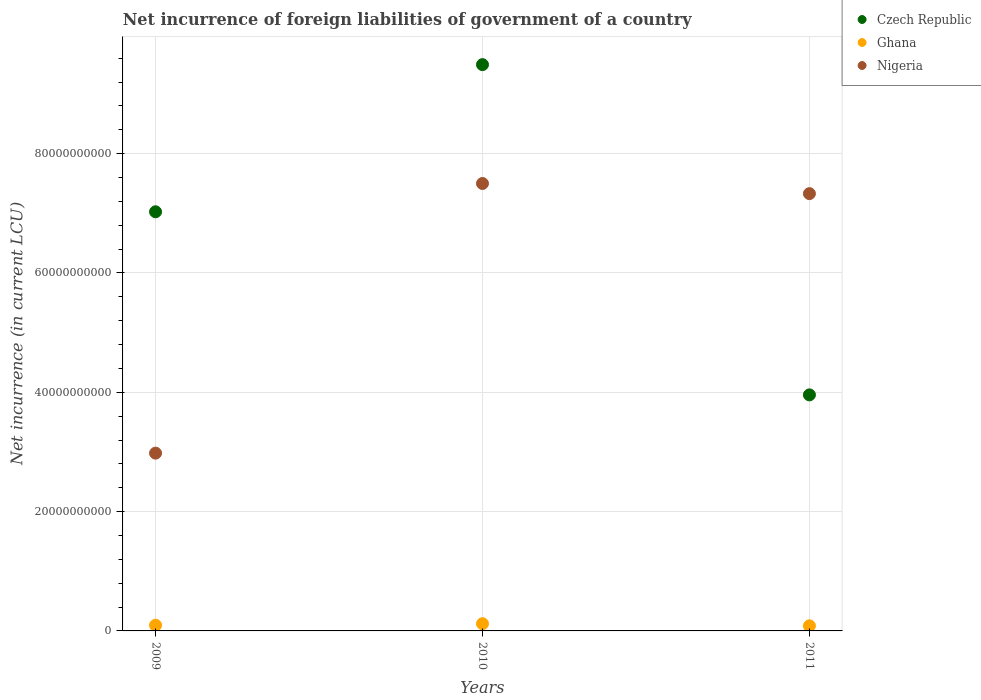How many different coloured dotlines are there?
Provide a short and direct response. 3. What is the net incurrence of foreign liabilities in Nigeria in 2010?
Give a very brief answer. 7.50e+1. Across all years, what is the maximum net incurrence of foreign liabilities in Ghana?
Provide a short and direct response. 1.21e+09. Across all years, what is the minimum net incurrence of foreign liabilities in Nigeria?
Keep it short and to the point. 2.98e+1. What is the total net incurrence of foreign liabilities in Ghana in the graph?
Make the answer very short. 3.02e+09. What is the difference between the net incurrence of foreign liabilities in Ghana in 2010 and that in 2011?
Make the answer very short. 3.53e+08. What is the difference between the net incurrence of foreign liabilities in Ghana in 2011 and the net incurrence of foreign liabilities in Nigeria in 2009?
Your answer should be compact. -2.89e+1. What is the average net incurrence of foreign liabilities in Nigeria per year?
Make the answer very short. 5.94e+1. In the year 2010, what is the difference between the net incurrence of foreign liabilities in Nigeria and net incurrence of foreign liabilities in Ghana?
Give a very brief answer. 7.38e+1. What is the ratio of the net incurrence of foreign liabilities in Nigeria in 2010 to that in 2011?
Give a very brief answer. 1.02. Is the net incurrence of foreign liabilities in Ghana in 2009 less than that in 2011?
Give a very brief answer. No. What is the difference between the highest and the second highest net incurrence of foreign liabilities in Nigeria?
Your answer should be very brief. 1.70e+09. What is the difference between the highest and the lowest net incurrence of foreign liabilities in Nigeria?
Your answer should be compact. 4.52e+1. In how many years, is the net incurrence of foreign liabilities in Nigeria greater than the average net incurrence of foreign liabilities in Nigeria taken over all years?
Ensure brevity in your answer.  2. Is it the case that in every year, the sum of the net incurrence of foreign liabilities in Nigeria and net incurrence of foreign liabilities in Ghana  is greater than the net incurrence of foreign liabilities in Czech Republic?
Offer a very short reply. No. Does the net incurrence of foreign liabilities in Czech Republic monotonically increase over the years?
Offer a very short reply. No. Is the net incurrence of foreign liabilities in Nigeria strictly greater than the net incurrence of foreign liabilities in Czech Republic over the years?
Provide a short and direct response. No. How many dotlines are there?
Provide a succinct answer. 3. How many years are there in the graph?
Your answer should be compact. 3. What is the difference between two consecutive major ticks on the Y-axis?
Your answer should be compact. 2.00e+1. Does the graph contain grids?
Keep it short and to the point. Yes. Where does the legend appear in the graph?
Provide a succinct answer. Top right. How many legend labels are there?
Your answer should be compact. 3. What is the title of the graph?
Provide a succinct answer. Net incurrence of foreign liabilities of government of a country. What is the label or title of the Y-axis?
Keep it short and to the point. Net incurrence (in current LCU). What is the Net incurrence (in current LCU) of Czech Republic in 2009?
Your response must be concise. 7.03e+1. What is the Net incurrence (in current LCU) in Ghana in 2009?
Offer a very short reply. 9.56e+08. What is the Net incurrence (in current LCU) of Nigeria in 2009?
Give a very brief answer. 2.98e+1. What is the Net incurrence (in current LCU) in Czech Republic in 2010?
Your answer should be compact. 9.49e+1. What is the Net incurrence (in current LCU) in Ghana in 2010?
Your answer should be very brief. 1.21e+09. What is the Net incurrence (in current LCU) in Nigeria in 2010?
Offer a terse response. 7.50e+1. What is the Net incurrence (in current LCU) in Czech Republic in 2011?
Make the answer very short. 3.96e+1. What is the Net incurrence (in current LCU) in Ghana in 2011?
Provide a short and direct response. 8.56e+08. What is the Net incurrence (in current LCU) in Nigeria in 2011?
Your answer should be very brief. 7.33e+1. Across all years, what is the maximum Net incurrence (in current LCU) in Czech Republic?
Offer a very short reply. 9.49e+1. Across all years, what is the maximum Net incurrence (in current LCU) in Ghana?
Make the answer very short. 1.21e+09. Across all years, what is the maximum Net incurrence (in current LCU) in Nigeria?
Provide a short and direct response. 7.50e+1. Across all years, what is the minimum Net incurrence (in current LCU) in Czech Republic?
Provide a succinct answer. 3.96e+1. Across all years, what is the minimum Net incurrence (in current LCU) in Ghana?
Offer a terse response. 8.56e+08. Across all years, what is the minimum Net incurrence (in current LCU) of Nigeria?
Your answer should be compact. 2.98e+1. What is the total Net incurrence (in current LCU) in Czech Republic in the graph?
Keep it short and to the point. 2.05e+11. What is the total Net incurrence (in current LCU) in Ghana in the graph?
Your answer should be compact. 3.02e+09. What is the total Net incurrence (in current LCU) of Nigeria in the graph?
Offer a very short reply. 1.78e+11. What is the difference between the Net incurrence (in current LCU) of Czech Republic in 2009 and that in 2010?
Your answer should be very brief. -2.47e+1. What is the difference between the Net incurrence (in current LCU) of Ghana in 2009 and that in 2010?
Ensure brevity in your answer.  -2.53e+08. What is the difference between the Net incurrence (in current LCU) in Nigeria in 2009 and that in 2010?
Make the answer very short. -4.52e+1. What is the difference between the Net incurrence (in current LCU) of Czech Republic in 2009 and that in 2011?
Give a very brief answer. 3.07e+1. What is the difference between the Net incurrence (in current LCU) of Ghana in 2009 and that in 2011?
Your answer should be compact. 9.93e+07. What is the difference between the Net incurrence (in current LCU) in Nigeria in 2009 and that in 2011?
Provide a succinct answer. -4.35e+1. What is the difference between the Net incurrence (in current LCU) in Czech Republic in 2010 and that in 2011?
Ensure brevity in your answer.  5.54e+1. What is the difference between the Net incurrence (in current LCU) in Ghana in 2010 and that in 2011?
Keep it short and to the point. 3.53e+08. What is the difference between the Net incurrence (in current LCU) in Nigeria in 2010 and that in 2011?
Your response must be concise. 1.70e+09. What is the difference between the Net incurrence (in current LCU) of Czech Republic in 2009 and the Net incurrence (in current LCU) of Ghana in 2010?
Provide a short and direct response. 6.90e+1. What is the difference between the Net incurrence (in current LCU) of Czech Republic in 2009 and the Net incurrence (in current LCU) of Nigeria in 2010?
Offer a terse response. -4.74e+09. What is the difference between the Net incurrence (in current LCU) of Ghana in 2009 and the Net incurrence (in current LCU) of Nigeria in 2010?
Keep it short and to the point. -7.40e+1. What is the difference between the Net incurrence (in current LCU) in Czech Republic in 2009 and the Net incurrence (in current LCU) in Ghana in 2011?
Give a very brief answer. 6.94e+1. What is the difference between the Net incurrence (in current LCU) of Czech Republic in 2009 and the Net incurrence (in current LCU) of Nigeria in 2011?
Provide a short and direct response. -3.04e+09. What is the difference between the Net incurrence (in current LCU) of Ghana in 2009 and the Net incurrence (in current LCU) of Nigeria in 2011?
Offer a terse response. -7.23e+1. What is the difference between the Net incurrence (in current LCU) of Czech Republic in 2010 and the Net incurrence (in current LCU) of Ghana in 2011?
Offer a very short reply. 9.41e+1. What is the difference between the Net incurrence (in current LCU) in Czech Republic in 2010 and the Net incurrence (in current LCU) in Nigeria in 2011?
Your response must be concise. 2.16e+1. What is the difference between the Net incurrence (in current LCU) in Ghana in 2010 and the Net incurrence (in current LCU) in Nigeria in 2011?
Give a very brief answer. -7.21e+1. What is the average Net incurrence (in current LCU) in Czech Republic per year?
Keep it short and to the point. 6.82e+1. What is the average Net incurrence (in current LCU) of Ghana per year?
Your answer should be compact. 1.01e+09. What is the average Net incurrence (in current LCU) of Nigeria per year?
Provide a short and direct response. 5.94e+1. In the year 2009, what is the difference between the Net incurrence (in current LCU) in Czech Republic and Net incurrence (in current LCU) in Ghana?
Provide a short and direct response. 6.93e+1. In the year 2009, what is the difference between the Net incurrence (in current LCU) in Czech Republic and Net incurrence (in current LCU) in Nigeria?
Ensure brevity in your answer.  4.05e+1. In the year 2009, what is the difference between the Net incurrence (in current LCU) in Ghana and Net incurrence (in current LCU) in Nigeria?
Make the answer very short. -2.88e+1. In the year 2010, what is the difference between the Net incurrence (in current LCU) in Czech Republic and Net incurrence (in current LCU) in Ghana?
Your answer should be compact. 9.37e+1. In the year 2010, what is the difference between the Net incurrence (in current LCU) of Czech Republic and Net incurrence (in current LCU) of Nigeria?
Offer a terse response. 1.99e+1. In the year 2010, what is the difference between the Net incurrence (in current LCU) of Ghana and Net incurrence (in current LCU) of Nigeria?
Ensure brevity in your answer.  -7.38e+1. In the year 2011, what is the difference between the Net incurrence (in current LCU) of Czech Republic and Net incurrence (in current LCU) of Ghana?
Provide a succinct answer. 3.87e+1. In the year 2011, what is the difference between the Net incurrence (in current LCU) in Czech Republic and Net incurrence (in current LCU) in Nigeria?
Provide a succinct answer. -3.37e+1. In the year 2011, what is the difference between the Net incurrence (in current LCU) in Ghana and Net incurrence (in current LCU) in Nigeria?
Give a very brief answer. -7.24e+1. What is the ratio of the Net incurrence (in current LCU) of Czech Republic in 2009 to that in 2010?
Offer a very short reply. 0.74. What is the ratio of the Net incurrence (in current LCU) of Ghana in 2009 to that in 2010?
Ensure brevity in your answer.  0.79. What is the ratio of the Net incurrence (in current LCU) in Nigeria in 2009 to that in 2010?
Provide a short and direct response. 0.4. What is the ratio of the Net incurrence (in current LCU) of Czech Republic in 2009 to that in 2011?
Ensure brevity in your answer.  1.78. What is the ratio of the Net incurrence (in current LCU) in Ghana in 2009 to that in 2011?
Your answer should be very brief. 1.12. What is the ratio of the Net incurrence (in current LCU) in Nigeria in 2009 to that in 2011?
Offer a very short reply. 0.41. What is the ratio of the Net incurrence (in current LCU) of Czech Republic in 2010 to that in 2011?
Provide a succinct answer. 2.4. What is the ratio of the Net incurrence (in current LCU) of Ghana in 2010 to that in 2011?
Make the answer very short. 1.41. What is the ratio of the Net incurrence (in current LCU) in Nigeria in 2010 to that in 2011?
Offer a very short reply. 1.02. What is the difference between the highest and the second highest Net incurrence (in current LCU) in Czech Republic?
Make the answer very short. 2.47e+1. What is the difference between the highest and the second highest Net incurrence (in current LCU) in Ghana?
Your answer should be compact. 2.53e+08. What is the difference between the highest and the second highest Net incurrence (in current LCU) in Nigeria?
Your response must be concise. 1.70e+09. What is the difference between the highest and the lowest Net incurrence (in current LCU) in Czech Republic?
Ensure brevity in your answer.  5.54e+1. What is the difference between the highest and the lowest Net incurrence (in current LCU) in Ghana?
Your answer should be compact. 3.53e+08. What is the difference between the highest and the lowest Net incurrence (in current LCU) in Nigeria?
Offer a very short reply. 4.52e+1. 